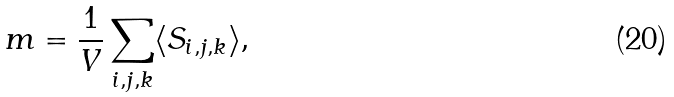<formula> <loc_0><loc_0><loc_500><loc_500>m = \frac { 1 } { V } \sum _ { i , j , k } \langle S _ { i , j , k } \rangle ,</formula> 